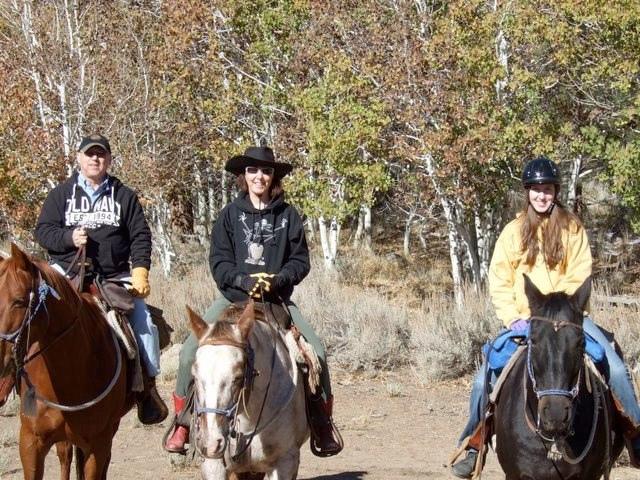Why do the horses have something on their head?
Be succinct. Control. Are these people enjoying riding the horses?
Give a very brief answer. Yes. What kind of jacket is the middle person wearing?
Keep it brief. Hoodie. 